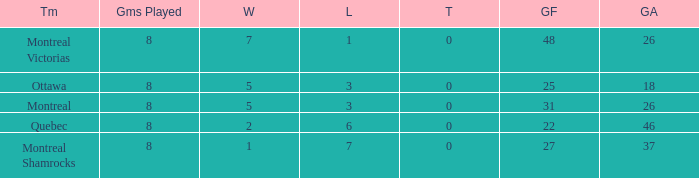For teams with more than 0 ties and goals against of 37, how many wins were tallied? None. 